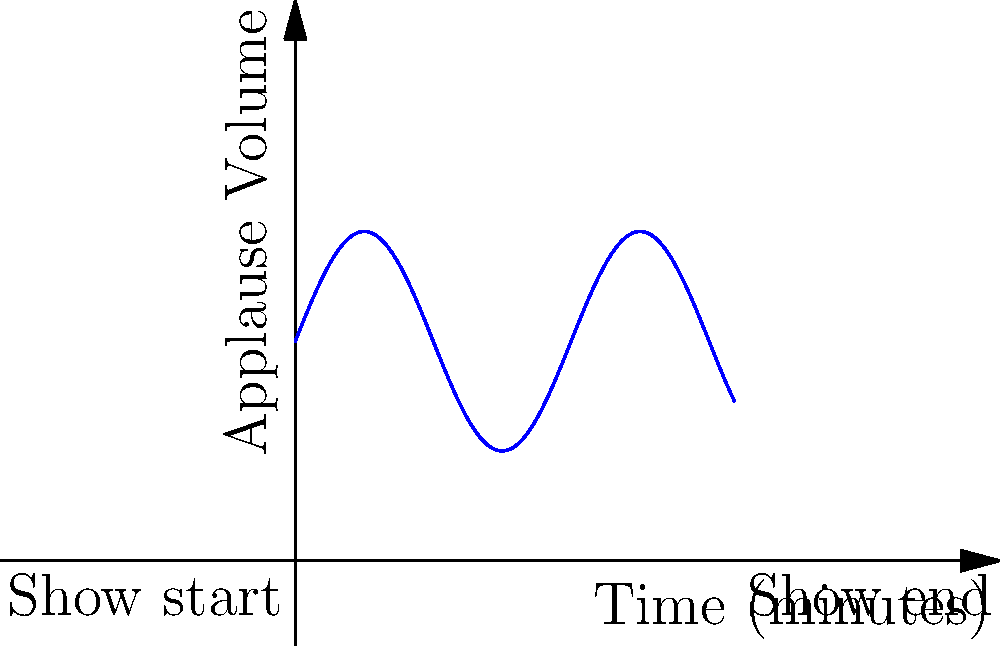As a mentalist, you've developed a mathematical model to analyze audience engagement during your shows. The graph above represents the applause volume over time during a 20-minute performance. The function describing this applause volume is given by $f(t) = 5\sin(\frac{t}{2}) + 10$, where $t$ is time in minutes and $f(t)$ is the applause volume. Calculate the total applause volume over the entire show by finding the area under the curve. How might this information be useful in refining your mentalism act? To calculate the total applause volume, we need to integrate the given function over the time interval [0, 20].

Step 1: Set up the definite integral
$$\int_0^{20} (5\sin(\frac{t}{2}) + 10) dt$$

Step 2: Integrate the function
First, let's integrate $5\sin(\frac{t}{2})$:
$$\int 5\sin(\frac{t}{2}) dt = -10\cos(\frac{t}{2}) + C$$

Now, integrate 10:
$$\int 10 dt = 10t + C$$

Step 3: Apply the fundamental theorem of calculus
$$[-10\cos(\frac{t}{2}) + 10t]_0^{20}$$

Step 4: Evaluate the integral
$$(-10\cos(10) + 200) - (-10\cos(0) + 0)$$
$$= -10\cos(10) + 200 + 10$$
$$= -10\cos(10) + 210$$

Step 5: Calculate the final result
$$\approx 201.84$$

This result represents the total applause volume over the entire 20-minute show.

As a mentalist, you could use this information to:
1. Identify peak moments of audience engagement
2. Adjust the pacing of your act to maintain consistent engagement
3. Compare different performances to optimize your routine
4. Correlate applause patterns with specific tricks or techniques
Answer: $201.84$ (approximate total applause volume) 